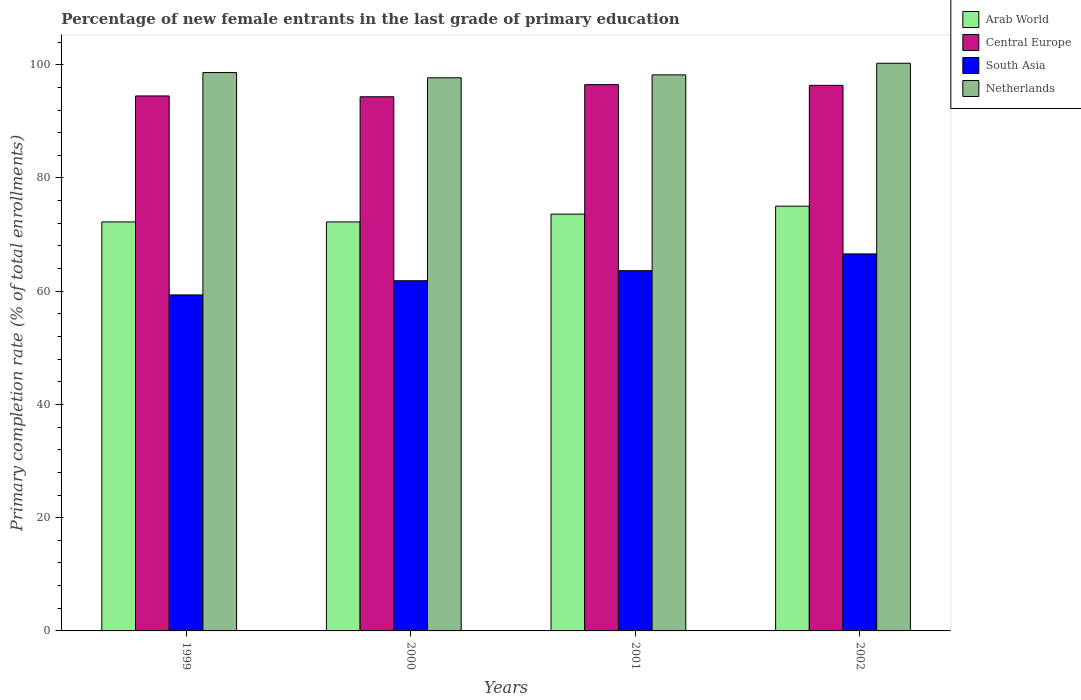What is the percentage of new female entrants in South Asia in 1999?
Provide a short and direct response. 59.35. Across all years, what is the maximum percentage of new female entrants in Central Europe?
Your answer should be very brief. 96.49. Across all years, what is the minimum percentage of new female entrants in South Asia?
Give a very brief answer. 59.35. In which year was the percentage of new female entrants in South Asia maximum?
Your response must be concise. 2002. What is the total percentage of new female entrants in Arab World in the graph?
Ensure brevity in your answer.  293.11. What is the difference between the percentage of new female entrants in South Asia in 2001 and that in 2002?
Make the answer very short. -2.96. What is the difference between the percentage of new female entrants in Arab World in 2001 and the percentage of new female entrants in South Asia in 1999?
Your answer should be very brief. 14.27. What is the average percentage of new female entrants in Netherlands per year?
Give a very brief answer. 98.7. In the year 2002, what is the difference between the percentage of new female entrants in Central Europe and percentage of new female entrants in Netherlands?
Keep it short and to the point. -3.9. What is the ratio of the percentage of new female entrants in Arab World in 2001 to that in 2002?
Provide a succinct answer. 0.98. Is the percentage of new female entrants in Arab World in 1999 less than that in 2000?
Your answer should be very brief. No. Is the difference between the percentage of new female entrants in Central Europe in 1999 and 2002 greater than the difference between the percentage of new female entrants in Netherlands in 1999 and 2002?
Provide a succinct answer. No. What is the difference between the highest and the second highest percentage of new female entrants in South Asia?
Your answer should be very brief. 2.96. What is the difference between the highest and the lowest percentage of new female entrants in Central Europe?
Offer a very short reply. 2.14. Is the sum of the percentage of new female entrants in Arab World in 1999 and 2000 greater than the maximum percentage of new female entrants in Central Europe across all years?
Provide a succinct answer. Yes. Is it the case that in every year, the sum of the percentage of new female entrants in South Asia and percentage of new female entrants in Central Europe is greater than the sum of percentage of new female entrants in Netherlands and percentage of new female entrants in Arab World?
Offer a very short reply. No. What does the 4th bar from the left in 2001 represents?
Your answer should be very brief. Netherlands. Is it the case that in every year, the sum of the percentage of new female entrants in Arab World and percentage of new female entrants in South Asia is greater than the percentage of new female entrants in Central Europe?
Give a very brief answer. Yes. How many years are there in the graph?
Your answer should be compact. 4. What is the difference between two consecutive major ticks on the Y-axis?
Provide a succinct answer. 20. Are the values on the major ticks of Y-axis written in scientific E-notation?
Offer a terse response. No. Does the graph contain any zero values?
Offer a terse response. No. Does the graph contain grids?
Offer a very short reply. No. How many legend labels are there?
Your answer should be very brief. 4. How are the legend labels stacked?
Your response must be concise. Vertical. What is the title of the graph?
Offer a very short reply. Percentage of new female entrants in the last grade of primary education. Does "Swaziland" appear as one of the legend labels in the graph?
Your answer should be compact. No. What is the label or title of the X-axis?
Your answer should be compact. Years. What is the label or title of the Y-axis?
Give a very brief answer. Primary completion rate (% of total enrollments). What is the Primary completion rate (% of total enrollments) of Arab World in 1999?
Provide a short and direct response. 72.24. What is the Primary completion rate (% of total enrollments) of Central Europe in 1999?
Give a very brief answer. 94.49. What is the Primary completion rate (% of total enrollments) in South Asia in 1999?
Give a very brief answer. 59.35. What is the Primary completion rate (% of total enrollments) of Netherlands in 1999?
Give a very brief answer. 98.62. What is the Primary completion rate (% of total enrollments) in Arab World in 2000?
Offer a very short reply. 72.24. What is the Primary completion rate (% of total enrollments) in Central Europe in 2000?
Your response must be concise. 94.35. What is the Primary completion rate (% of total enrollments) of South Asia in 2000?
Your answer should be very brief. 61.85. What is the Primary completion rate (% of total enrollments) of Netherlands in 2000?
Keep it short and to the point. 97.7. What is the Primary completion rate (% of total enrollments) of Arab World in 2001?
Make the answer very short. 73.62. What is the Primary completion rate (% of total enrollments) in Central Europe in 2001?
Offer a very short reply. 96.49. What is the Primary completion rate (% of total enrollments) in South Asia in 2001?
Your answer should be very brief. 63.63. What is the Primary completion rate (% of total enrollments) in Netherlands in 2001?
Offer a very short reply. 98.21. What is the Primary completion rate (% of total enrollments) in Arab World in 2002?
Your answer should be very brief. 75.02. What is the Primary completion rate (% of total enrollments) of Central Europe in 2002?
Your answer should be compact. 96.36. What is the Primary completion rate (% of total enrollments) in South Asia in 2002?
Provide a short and direct response. 66.59. What is the Primary completion rate (% of total enrollments) in Netherlands in 2002?
Make the answer very short. 100.26. Across all years, what is the maximum Primary completion rate (% of total enrollments) in Arab World?
Give a very brief answer. 75.02. Across all years, what is the maximum Primary completion rate (% of total enrollments) in Central Europe?
Make the answer very short. 96.49. Across all years, what is the maximum Primary completion rate (% of total enrollments) in South Asia?
Provide a succinct answer. 66.59. Across all years, what is the maximum Primary completion rate (% of total enrollments) in Netherlands?
Make the answer very short. 100.26. Across all years, what is the minimum Primary completion rate (% of total enrollments) of Arab World?
Give a very brief answer. 72.24. Across all years, what is the minimum Primary completion rate (% of total enrollments) of Central Europe?
Keep it short and to the point. 94.35. Across all years, what is the minimum Primary completion rate (% of total enrollments) in South Asia?
Your answer should be compact. 59.35. Across all years, what is the minimum Primary completion rate (% of total enrollments) in Netherlands?
Your answer should be compact. 97.7. What is the total Primary completion rate (% of total enrollments) of Arab World in the graph?
Your answer should be compact. 293.11. What is the total Primary completion rate (% of total enrollments) of Central Europe in the graph?
Make the answer very short. 381.69. What is the total Primary completion rate (% of total enrollments) in South Asia in the graph?
Offer a very short reply. 251.42. What is the total Primary completion rate (% of total enrollments) in Netherlands in the graph?
Keep it short and to the point. 394.8. What is the difference between the Primary completion rate (% of total enrollments) of Arab World in 1999 and that in 2000?
Give a very brief answer. 0. What is the difference between the Primary completion rate (% of total enrollments) of Central Europe in 1999 and that in 2000?
Offer a very short reply. 0.14. What is the difference between the Primary completion rate (% of total enrollments) of South Asia in 1999 and that in 2000?
Offer a very short reply. -2.51. What is the difference between the Primary completion rate (% of total enrollments) in Netherlands in 1999 and that in 2000?
Provide a succinct answer. 0.92. What is the difference between the Primary completion rate (% of total enrollments) in Arab World in 1999 and that in 2001?
Provide a succinct answer. -1.38. What is the difference between the Primary completion rate (% of total enrollments) of Central Europe in 1999 and that in 2001?
Your answer should be compact. -2. What is the difference between the Primary completion rate (% of total enrollments) in South Asia in 1999 and that in 2001?
Keep it short and to the point. -4.28. What is the difference between the Primary completion rate (% of total enrollments) of Netherlands in 1999 and that in 2001?
Keep it short and to the point. 0.41. What is the difference between the Primary completion rate (% of total enrollments) in Arab World in 1999 and that in 2002?
Ensure brevity in your answer.  -2.78. What is the difference between the Primary completion rate (% of total enrollments) of Central Europe in 1999 and that in 2002?
Give a very brief answer. -1.87. What is the difference between the Primary completion rate (% of total enrollments) in South Asia in 1999 and that in 2002?
Ensure brevity in your answer.  -7.24. What is the difference between the Primary completion rate (% of total enrollments) in Netherlands in 1999 and that in 2002?
Give a very brief answer. -1.64. What is the difference between the Primary completion rate (% of total enrollments) of Arab World in 2000 and that in 2001?
Ensure brevity in your answer.  -1.38. What is the difference between the Primary completion rate (% of total enrollments) of Central Europe in 2000 and that in 2001?
Provide a succinct answer. -2.14. What is the difference between the Primary completion rate (% of total enrollments) in South Asia in 2000 and that in 2001?
Provide a short and direct response. -1.77. What is the difference between the Primary completion rate (% of total enrollments) of Netherlands in 2000 and that in 2001?
Provide a succinct answer. -0.52. What is the difference between the Primary completion rate (% of total enrollments) of Arab World in 2000 and that in 2002?
Provide a succinct answer. -2.79. What is the difference between the Primary completion rate (% of total enrollments) in Central Europe in 2000 and that in 2002?
Provide a short and direct response. -2.02. What is the difference between the Primary completion rate (% of total enrollments) of South Asia in 2000 and that in 2002?
Offer a very short reply. -4.74. What is the difference between the Primary completion rate (% of total enrollments) in Netherlands in 2000 and that in 2002?
Provide a succinct answer. -2.57. What is the difference between the Primary completion rate (% of total enrollments) in Arab World in 2001 and that in 2002?
Make the answer very short. -1.41. What is the difference between the Primary completion rate (% of total enrollments) in Central Europe in 2001 and that in 2002?
Provide a short and direct response. 0.13. What is the difference between the Primary completion rate (% of total enrollments) of South Asia in 2001 and that in 2002?
Your response must be concise. -2.96. What is the difference between the Primary completion rate (% of total enrollments) of Netherlands in 2001 and that in 2002?
Your response must be concise. -2.05. What is the difference between the Primary completion rate (% of total enrollments) in Arab World in 1999 and the Primary completion rate (% of total enrollments) in Central Europe in 2000?
Provide a short and direct response. -22.11. What is the difference between the Primary completion rate (% of total enrollments) of Arab World in 1999 and the Primary completion rate (% of total enrollments) of South Asia in 2000?
Ensure brevity in your answer.  10.39. What is the difference between the Primary completion rate (% of total enrollments) in Arab World in 1999 and the Primary completion rate (% of total enrollments) in Netherlands in 2000?
Offer a very short reply. -25.46. What is the difference between the Primary completion rate (% of total enrollments) of Central Europe in 1999 and the Primary completion rate (% of total enrollments) of South Asia in 2000?
Your answer should be compact. 32.64. What is the difference between the Primary completion rate (% of total enrollments) of Central Europe in 1999 and the Primary completion rate (% of total enrollments) of Netherlands in 2000?
Ensure brevity in your answer.  -3.21. What is the difference between the Primary completion rate (% of total enrollments) in South Asia in 1999 and the Primary completion rate (% of total enrollments) in Netherlands in 2000?
Keep it short and to the point. -38.35. What is the difference between the Primary completion rate (% of total enrollments) of Arab World in 1999 and the Primary completion rate (% of total enrollments) of Central Europe in 2001?
Offer a terse response. -24.25. What is the difference between the Primary completion rate (% of total enrollments) in Arab World in 1999 and the Primary completion rate (% of total enrollments) in South Asia in 2001?
Offer a very short reply. 8.61. What is the difference between the Primary completion rate (% of total enrollments) of Arab World in 1999 and the Primary completion rate (% of total enrollments) of Netherlands in 2001?
Ensure brevity in your answer.  -25.97. What is the difference between the Primary completion rate (% of total enrollments) in Central Europe in 1999 and the Primary completion rate (% of total enrollments) in South Asia in 2001?
Give a very brief answer. 30.86. What is the difference between the Primary completion rate (% of total enrollments) of Central Europe in 1999 and the Primary completion rate (% of total enrollments) of Netherlands in 2001?
Your response must be concise. -3.72. What is the difference between the Primary completion rate (% of total enrollments) of South Asia in 1999 and the Primary completion rate (% of total enrollments) of Netherlands in 2001?
Make the answer very short. -38.87. What is the difference between the Primary completion rate (% of total enrollments) in Arab World in 1999 and the Primary completion rate (% of total enrollments) in Central Europe in 2002?
Keep it short and to the point. -24.12. What is the difference between the Primary completion rate (% of total enrollments) of Arab World in 1999 and the Primary completion rate (% of total enrollments) of South Asia in 2002?
Offer a terse response. 5.65. What is the difference between the Primary completion rate (% of total enrollments) of Arab World in 1999 and the Primary completion rate (% of total enrollments) of Netherlands in 2002?
Keep it short and to the point. -28.03. What is the difference between the Primary completion rate (% of total enrollments) of Central Europe in 1999 and the Primary completion rate (% of total enrollments) of South Asia in 2002?
Your response must be concise. 27.9. What is the difference between the Primary completion rate (% of total enrollments) of Central Europe in 1999 and the Primary completion rate (% of total enrollments) of Netherlands in 2002?
Offer a very short reply. -5.77. What is the difference between the Primary completion rate (% of total enrollments) in South Asia in 1999 and the Primary completion rate (% of total enrollments) in Netherlands in 2002?
Offer a very short reply. -40.92. What is the difference between the Primary completion rate (% of total enrollments) of Arab World in 2000 and the Primary completion rate (% of total enrollments) of Central Europe in 2001?
Make the answer very short. -24.25. What is the difference between the Primary completion rate (% of total enrollments) of Arab World in 2000 and the Primary completion rate (% of total enrollments) of South Asia in 2001?
Provide a short and direct response. 8.61. What is the difference between the Primary completion rate (% of total enrollments) in Arab World in 2000 and the Primary completion rate (% of total enrollments) in Netherlands in 2001?
Your answer should be compact. -25.98. What is the difference between the Primary completion rate (% of total enrollments) of Central Europe in 2000 and the Primary completion rate (% of total enrollments) of South Asia in 2001?
Provide a short and direct response. 30.72. What is the difference between the Primary completion rate (% of total enrollments) of Central Europe in 2000 and the Primary completion rate (% of total enrollments) of Netherlands in 2001?
Offer a terse response. -3.87. What is the difference between the Primary completion rate (% of total enrollments) of South Asia in 2000 and the Primary completion rate (% of total enrollments) of Netherlands in 2001?
Your response must be concise. -36.36. What is the difference between the Primary completion rate (% of total enrollments) in Arab World in 2000 and the Primary completion rate (% of total enrollments) in Central Europe in 2002?
Provide a short and direct response. -24.13. What is the difference between the Primary completion rate (% of total enrollments) in Arab World in 2000 and the Primary completion rate (% of total enrollments) in South Asia in 2002?
Make the answer very short. 5.65. What is the difference between the Primary completion rate (% of total enrollments) in Arab World in 2000 and the Primary completion rate (% of total enrollments) in Netherlands in 2002?
Keep it short and to the point. -28.03. What is the difference between the Primary completion rate (% of total enrollments) in Central Europe in 2000 and the Primary completion rate (% of total enrollments) in South Asia in 2002?
Offer a terse response. 27.76. What is the difference between the Primary completion rate (% of total enrollments) in Central Europe in 2000 and the Primary completion rate (% of total enrollments) in Netherlands in 2002?
Provide a short and direct response. -5.92. What is the difference between the Primary completion rate (% of total enrollments) of South Asia in 2000 and the Primary completion rate (% of total enrollments) of Netherlands in 2002?
Ensure brevity in your answer.  -38.41. What is the difference between the Primary completion rate (% of total enrollments) in Arab World in 2001 and the Primary completion rate (% of total enrollments) in Central Europe in 2002?
Ensure brevity in your answer.  -22.75. What is the difference between the Primary completion rate (% of total enrollments) of Arab World in 2001 and the Primary completion rate (% of total enrollments) of South Asia in 2002?
Offer a terse response. 7.03. What is the difference between the Primary completion rate (% of total enrollments) in Arab World in 2001 and the Primary completion rate (% of total enrollments) in Netherlands in 2002?
Make the answer very short. -26.65. What is the difference between the Primary completion rate (% of total enrollments) in Central Europe in 2001 and the Primary completion rate (% of total enrollments) in South Asia in 2002?
Your response must be concise. 29.9. What is the difference between the Primary completion rate (% of total enrollments) of Central Europe in 2001 and the Primary completion rate (% of total enrollments) of Netherlands in 2002?
Your response must be concise. -3.78. What is the difference between the Primary completion rate (% of total enrollments) of South Asia in 2001 and the Primary completion rate (% of total enrollments) of Netherlands in 2002?
Ensure brevity in your answer.  -36.64. What is the average Primary completion rate (% of total enrollments) in Arab World per year?
Give a very brief answer. 73.28. What is the average Primary completion rate (% of total enrollments) in Central Europe per year?
Offer a very short reply. 95.42. What is the average Primary completion rate (% of total enrollments) in South Asia per year?
Keep it short and to the point. 62.85. What is the average Primary completion rate (% of total enrollments) in Netherlands per year?
Your answer should be compact. 98.7. In the year 1999, what is the difference between the Primary completion rate (% of total enrollments) of Arab World and Primary completion rate (% of total enrollments) of Central Europe?
Your answer should be compact. -22.25. In the year 1999, what is the difference between the Primary completion rate (% of total enrollments) of Arab World and Primary completion rate (% of total enrollments) of South Asia?
Ensure brevity in your answer.  12.89. In the year 1999, what is the difference between the Primary completion rate (% of total enrollments) of Arab World and Primary completion rate (% of total enrollments) of Netherlands?
Provide a short and direct response. -26.38. In the year 1999, what is the difference between the Primary completion rate (% of total enrollments) in Central Europe and Primary completion rate (% of total enrollments) in South Asia?
Offer a terse response. 35.14. In the year 1999, what is the difference between the Primary completion rate (% of total enrollments) in Central Europe and Primary completion rate (% of total enrollments) in Netherlands?
Ensure brevity in your answer.  -4.13. In the year 1999, what is the difference between the Primary completion rate (% of total enrollments) of South Asia and Primary completion rate (% of total enrollments) of Netherlands?
Your response must be concise. -39.27. In the year 2000, what is the difference between the Primary completion rate (% of total enrollments) in Arab World and Primary completion rate (% of total enrollments) in Central Europe?
Provide a short and direct response. -22.11. In the year 2000, what is the difference between the Primary completion rate (% of total enrollments) of Arab World and Primary completion rate (% of total enrollments) of South Asia?
Give a very brief answer. 10.38. In the year 2000, what is the difference between the Primary completion rate (% of total enrollments) of Arab World and Primary completion rate (% of total enrollments) of Netherlands?
Offer a very short reply. -25.46. In the year 2000, what is the difference between the Primary completion rate (% of total enrollments) in Central Europe and Primary completion rate (% of total enrollments) in South Asia?
Keep it short and to the point. 32.49. In the year 2000, what is the difference between the Primary completion rate (% of total enrollments) in Central Europe and Primary completion rate (% of total enrollments) in Netherlands?
Offer a very short reply. -3.35. In the year 2000, what is the difference between the Primary completion rate (% of total enrollments) of South Asia and Primary completion rate (% of total enrollments) of Netherlands?
Keep it short and to the point. -35.84. In the year 2001, what is the difference between the Primary completion rate (% of total enrollments) of Arab World and Primary completion rate (% of total enrollments) of Central Europe?
Give a very brief answer. -22.87. In the year 2001, what is the difference between the Primary completion rate (% of total enrollments) in Arab World and Primary completion rate (% of total enrollments) in South Asia?
Your answer should be very brief. 9.99. In the year 2001, what is the difference between the Primary completion rate (% of total enrollments) in Arab World and Primary completion rate (% of total enrollments) in Netherlands?
Give a very brief answer. -24.6. In the year 2001, what is the difference between the Primary completion rate (% of total enrollments) of Central Europe and Primary completion rate (% of total enrollments) of South Asia?
Your answer should be compact. 32.86. In the year 2001, what is the difference between the Primary completion rate (% of total enrollments) of Central Europe and Primary completion rate (% of total enrollments) of Netherlands?
Offer a terse response. -1.72. In the year 2001, what is the difference between the Primary completion rate (% of total enrollments) of South Asia and Primary completion rate (% of total enrollments) of Netherlands?
Provide a short and direct response. -34.59. In the year 2002, what is the difference between the Primary completion rate (% of total enrollments) in Arab World and Primary completion rate (% of total enrollments) in Central Europe?
Ensure brevity in your answer.  -21.34. In the year 2002, what is the difference between the Primary completion rate (% of total enrollments) of Arab World and Primary completion rate (% of total enrollments) of South Asia?
Your response must be concise. 8.43. In the year 2002, what is the difference between the Primary completion rate (% of total enrollments) in Arab World and Primary completion rate (% of total enrollments) in Netherlands?
Make the answer very short. -25.24. In the year 2002, what is the difference between the Primary completion rate (% of total enrollments) in Central Europe and Primary completion rate (% of total enrollments) in South Asia?
Offer a terse response. 29.77. In the year 2002, what is the difference between the Primary completion rate (% of total enrollments) of Central Europe and Primary completion rate (% of total enrollments) of Netherlands?
Give a very brief answer. -3.9. In the year 2002, what is the difference between the Primary completion rate (% of total enrollments) of South Asia and Primary completion rate (% of total enrollments) of Netherlands?
Keep it short and to the point. -33.67. What is the ratio of the Primary completion rate (% of total enrollments) in Central Europe in 1999 to that in 2000?
Provide a succinct answer. 1. What is the ratio of the Primary completion rate (% of total enrollments) of South Asia in 1999 to that in 2000?
Your response must be concise. 0.96. What is the ratio of the Primary completion rate (% of total enrollments) in Netherlands in 1999 to that in 2000?
Make the answer very short. 1.01. What is the ratio of the Primary completion rate (% of total enrollments) in Arab World in 1999 to that in 2001?
Offer a very short reply. 0.98. What is the ratio of the Primary completion rate (% of total enrollments) in Central Europe in 1999 to that in 2001?
Your response must be concise. 0.98. What is the ratio of the Primary completion rate (% of total enrollments) in South Asia in 1999 to that in 2001?
Your response must be concise. 0.93. What is the ratio of the Primary completion rate (% of total enrollments) of Arab World in 1999 to that in 2002?
Offer a very short reply. 0.96. What is the ratio of the Primary completion rate (% of total enrollments) of Central Europe in 1999 to that in 2002?
Your response must be concise. 0.98. What is the ratio of the Primary completion rate (% of total enrollments) in South Asia in 1999 to that in 2002?
Ensure brevity in your answer.  0.89. What is the ratio of the Primary completion rate (% of total enrollments) in Netherlands in 1999 to that in 2002?
Provide a short and direct response. 0.98. What is the ratio of the Primary completion rate (% of total enrollments) in Arab World in 2000 to that in 2001?
Offer a very short reply. 0.98. What is the ratio of the Primary completion rate (% of total enrollments) in Central Europe in 2000 to that in 2001?
Provide a short and direct response. 0.98. What is the ratio of the Primary completion rate (% of total enrollments) in South Asia in 2000 to that in 2001?
Provide a succinct answer. 0.97. What is the ratio of the Primary completion rate (% of total enrollments) in Netherlands in 2000 to that in 2001?
Your answer should be very brief. 0.99. What is the ratio of the Primary completion rate (% of total enrollments) of Arab World in 2000 to that in 2002?
Your answer should be compact. 0.96. What is the ratio of the Primary completion rate (% of total enrollments) in Central Europe in 2000 to that in 2002?
Make the answer very short. 0.98. What is the ratio of the Primary completion rate (% of total enrollments) of South Asia in 2000 to that in 2002?
Give a very brief answer. 0.93. What is the ratio of the Primary completion rate (% of total enrollments) in Netherlands in 2000 to that in 2002?
Your answer should be compact. 0.97. What is the ratio of the Primary completion rate (% of total enrollments) in Arab World in 2001 to that in 2002?
Offer a terse response. 0.98. What is the ratio of the Primary completion rate (% of total enrollments) in Central Europe in 2001 to that in 2002?
Your response must be concise. 1. What is the ratio of the Primary completion rate (% of total enrollments) of South Asia in 2001 to that in 2002?
Provide a succinct answer. 0.96. What is the ratio of the Primary completion rate (% of total enrollments) of Netherlands in 2001 to that in 2002?
Offer a very short reply. 0.98. What is the difference between the highest and the second highest Primary completion rate (% of total enrollments) of Arab World?
Make the answer very short. 1.41. What is the difference between the highest and the second highest Primary completion rate (% of total enrollments) in Central Europe?
Provide a succinct answer. 0.13. What is the difference between the highest and the second highest Primary completion rate (% of total enrollments) of South Asia?
Offer a terse response. 2.96. What is the difference between the highest and the second highest Primary completion rate (% of total enrollments) in Netherlands?
Give a very brief answer. 1.64. What is the difference between the highest and the lowest Primary completion rate (% of total enrollments) of Arab World?
Give a very brief answer. 2.79. What is the difference between the highest and the lowest Primary completion rate (% of total enrollments) of Central Europe?
Ensure brevity in your answer.  2.14. What is the difference between the highest and the lowest Primary completion rate (% of total enrollments) of South Asia?
Give a very brief answer. 7.24. What is the difference between the highest and the lowest Primary completion rate (% of total enrollments) of Netherlands?
Keep it short and to the point. 2.57. 